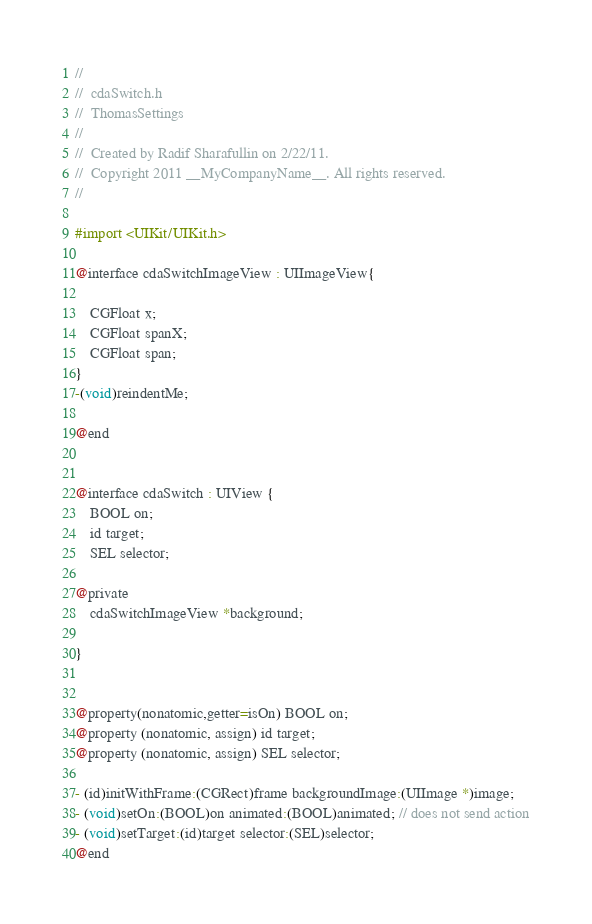<code> <loc_0><loc_0><loc_500><loc_500><_C_>//
//  cdaSwitch.h
//  ThomasSettings
//
//  Created by Radif Sharafullin on 2/22/11.
//  Copyright 2011 __MyCompanyName__. All rights reserved.
//

#import <UIKit/UIKit.h>

@interface cdaSwitchImageView : UIImageView{

	CGFloat x;
	CGFloat spanX;
	CGFloat span;
}
-(void)reindentMe;

@end


@interface cdaSwitch : UIView {
	BOOL on;
	id target;
	SEL selector;
	
@private
	cdaSwitchImageView *background;
	
}


@property(nonatomic,getter=isOn) BOOL on;
@property (nonatomic, assign) id target;
@property (nonatomic, assign) SEL selector;

- (id)initWithFrame:(CGRect)frame backgroundImage:(UIImage *)image;
- (void)setOn:(BOOL)on animated:(BOOL)animated; // does not send action
- (void)setTarget:(id)target selector:(SEL)selector;
@end
</code> 